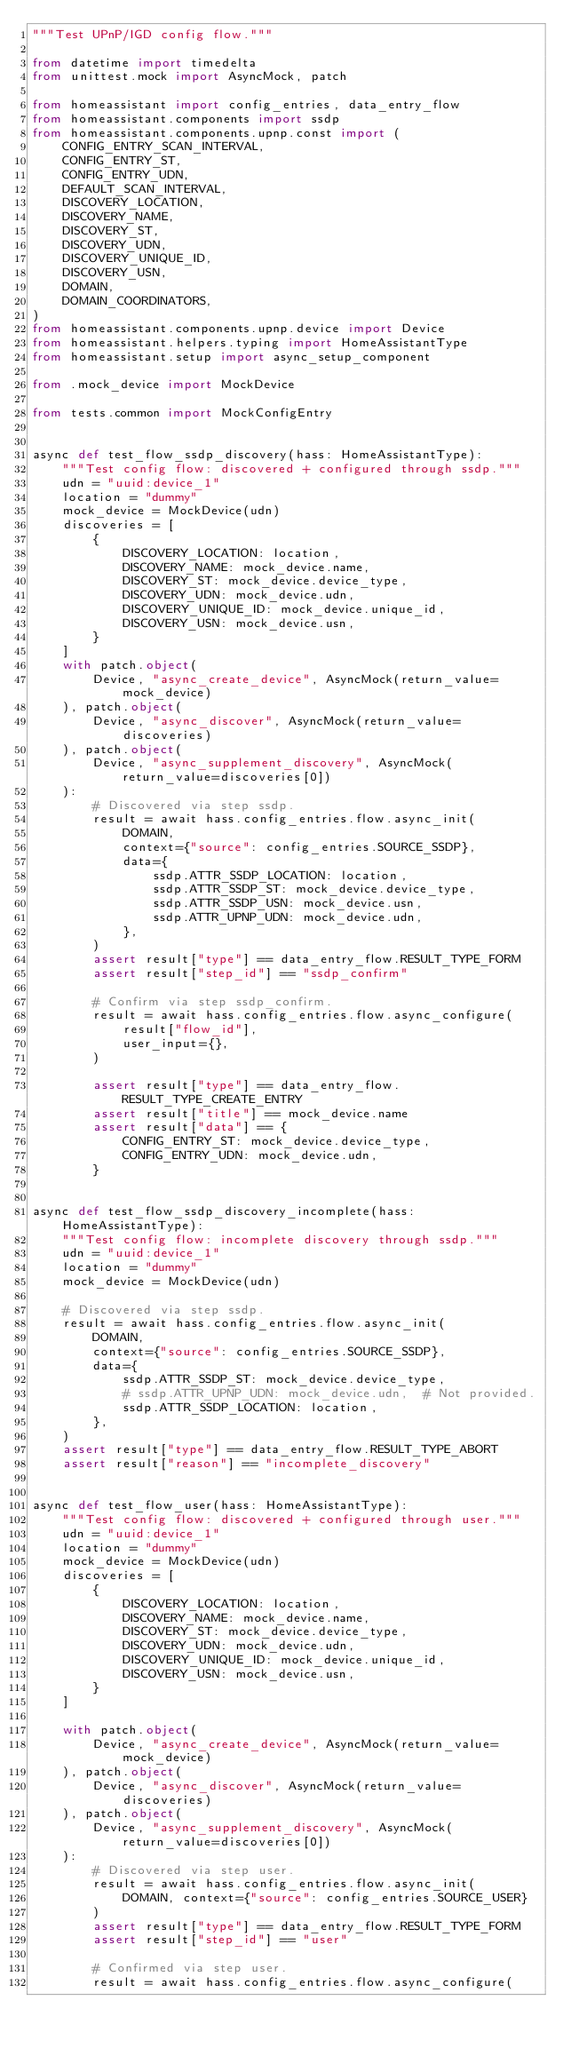<code> <loc_0><loc_0><loc_500><loc_500><_Python_>"""Test UPnP/IGD config flow."""

from datetime import timedelta
from unittest.mock import AsyncMock, patch

from homeassistant import config_entries, data_entry_flow
from homeassistant.components import ssdp
from homeassistant.components.upnp.const import (
    CONFIG_ENTRY_SCAN_INTERVAL,
    CONFIG_ENTRY_ST,
    CONFIG_ENTRY_UDN,
    DEFAULT_SCAN_INTERVAL,
    DISCOVERY_LOCATION,
    DISCOVERY_NAME,
    DISCOVERY_ST,
    DISCOVERY_UDN,
    DISCOVERY_UNIQUE_ID,
    DISCOVERY_USN,
    DOMAIN,
    DOMAIN_COORDINATORS,
)
from homeassistant.components.upnp.device import Device
from homeassistant.helpers.typing import HomeAssistantType
from homeassistant.setup import async_setup_component

from .mock_device import MockDevice

from tests.common import MockConfigEntry


async def test_flow_ssdp_discovery(hass: HomeAssistantType):
    """Test config flow: discovered + configured through ssdp."""
    udn = "uuid:device_1"
    location = "dummy"
    mock_device = MockDevice(udn)
    discoveries = [
        {
            DISCOVERY_LOCATION: location,
            DISCOVERY_NAME: mock_device.name,
            DISCOVERY_ST: mock_device.device_type,
            DISCOVERY_UDN: mock_device.udn,
            DISCOVERY_UNIQUE_ID: mock_device.unique_id,
            DISCOVERY_USN: mock_device.usn,
        }
    ]
    with patch.object(
        Device, "async_create_device", AsyncMock(return_value=mock_device)
    ), patch.object(
        Device, "async_discover", AsyncMock(return_value=discoveries)
    ), patch.object(
        Device, "async_supplement_discovery", AsyncMock(return_value=discoveries[0])
    ):
        # Discovered via step ssdp.
        result = await hass.config_entries.flow.async_init(
            DOMAIN,
            context={"source": config_entries.SOURCE_SSDP},
            data={
                ssdp.ATTR_SSDP_LOCATION: location,
                ssdp.ATTR_SSDP_ST: mock_device.device_type,
                ssdp.ATTR_SSDP_USN: mock_device.usn,
                ssdp.ATTR_UPNP_UDN: mock_device.udn,
            },
        )
        assert result["type"] == data_entry_flow.RESULT_TYPE_FORM
        assert result["step_id"] == "ssdp_confirm"

        # Confirm via step ssdp_confirm.
        result = await hass.config_entries.flow.async_configure(
            result["flow_id"],
            user_input={},
        )

        assert result["type"] == data_entry_flow.RESULT_TYPE_CREATE_ENTRY
        assert result["title"] == mock_device.name
        assert result["data"] == {
            CONFIG_ENTRY_ST: mock_device.device_type,
            CONFIG_ENTRY_UDN: mock_device.udn,
        }


async def test_flow_ssdp_discovery_incomplete(hass: HomeAssistantType):
    """Test config flow: incomplete discovery through ssdp."""
    udn = "uuid:device_1"
    location = "dummy"
    mock_device = MockDevice(udn)

    # Discovered via step ssdp.
    result = await hass.config_entries.flow.async_init(
        DOMAIN,
        context={"source": config_entries.SOURCE_SSDP},
        data={
            ssdp.ATTR_SSDP_ST: mock_device.device_type,
            # ssdp.ATTR_UPNP_UDN: mock_device.udn,  # Not provided.
            ssdp.ATTR_SSDP_LOCATION: location,
        },
    )
    assert result["type"] == data_entry_flow.RESULT_TYPE_ABORT
    assert result["reason"] == "incomplete_discovery"


async def test_flow_user(hass: HomeAssistantType):
    """Test config flow: discovered + configured through user."""
    udn = "uuid:device_1"
    location = "dummy"
    mock_device = MockDevice(udn)
    discoveries = [
        {
            DISCOVERY_LOCATION: location,
            DISCOVERY_NAME: mock_device.name,
            DISCOVERY_ST: mock_device.device_type,
            DISCOVERY_UDN: mock_device.udn,
            DISCOVERY_UNIQUE_ID: mock_device.unique_id,
            DISCOVERY_USN: mock_device.usn,
        }
    ]

    with patch.object(
        Device, "async_create_device", AsyncMock(return_value=mock_device)
    ), patch.object(
        Device, "async_discover", AsyncMock(return_value=discoveries)
    ), patch.object(
        Device, "async_supplement_discovery", AsyncMock(return_value=discoveries[0])
    ):
        # Discovered via step user.
        result = await hass.config_entries.flow.async_init(
            DOMAIN, context={"source": config_entries.SOURCE_USER}
        )
        assert result["type"] == data_entry_flow.RESULT_TYPE_FORM
        assert result["step_id"] == "user"

        # Confirmed via step user.
        result = await hass.config_entries.flow.async_configure(</code> 